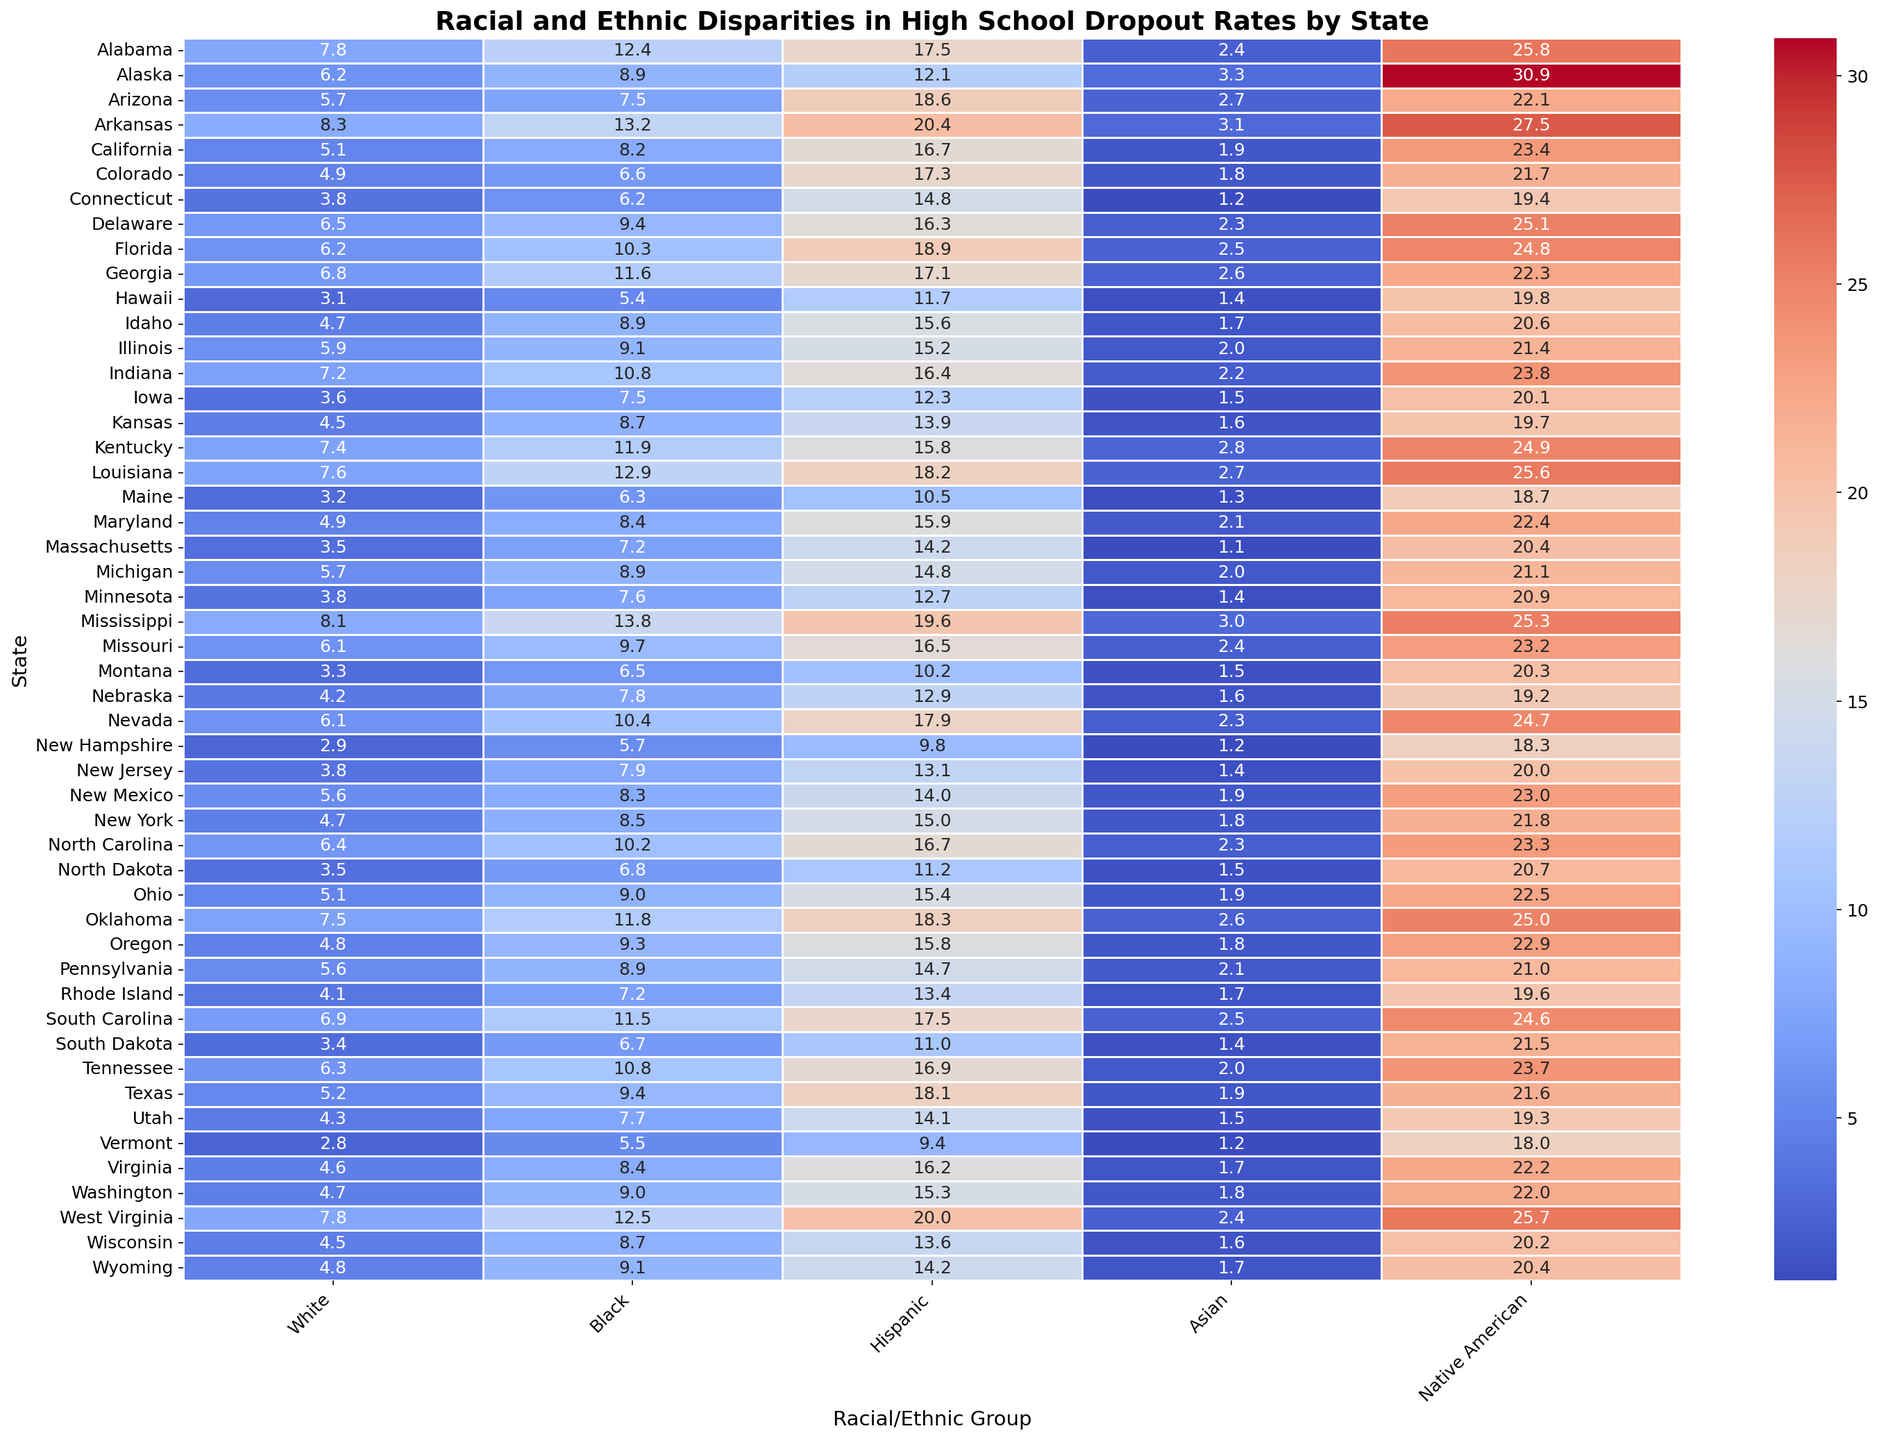What is the average dropout rate for Hispanic students across all states? To find the average dropout rate for Hispanic students, sum up all the dropout rates for the Hispanic column and divide by the number of states (50). Sum = 17.5 + 12.1 + 18.6 + 20.4 + 16.7 + 17.3 + 14.8 + 16.3 + 18.9 + 17.1 + 11.7 + 15.6 + 15.2 + 16.4 + 12.3 + 13.9 + 15.8 + 18.2 + 10.5 + 15.9 + 14.2 + 14.8 + 12.7 + 19.6 + 16.5 + 10.2 + 12.9 + 17.9 + 9.8 + 13.1 + 14.0 + 15.0 + 16.7 + 11.2 + 15.4 + 18.3 + 15.8 + 14.7 + 13.4 + 17.5 + 11.0 + 16.9 + 18.1 + 14.1 + 9.4 + 16.2 + 15.3 + 20.0 + 14.2 = 747.0. Average = 747.0 / 50 = 14.9
Answer: 14.9 Which state has the highest dropout rate for Native American students, and what is the rate? To find the state with the highest dropout rate for Native American students, scan through the Native American column and identify the maximum value and corresponding state. The highest rate is in Alaska with a 30.9% dropout rate.
Answer: Alaska, 30.9% How does the dropout rate for Black students in Mississippi compare to that in Kentucky? Look at the dropout rates for Black students in Mississippi and Kentucky, which are 13.8% and 11.9% respectively. Subtract 11.9 from 13.8 to find the difference. Mississippi's rate is 1.9 percentage points higher.
Answer: Mississippi, 1.9 percentage points higher What is the difference in dropout rates between White and Asian students in California? Subtract the dropout rate of Asian students in California (1.9%) from that of White students (5.1%). The difference is 5.1% - 1.9% = 3.2%.
Answer: 3.2% Which racial/ethnic group has the lowest dropout rate in New York? Look at the dropout rates for New York across all racial/ethnic groups: White (4.7%), Black (8.5%), Hispanic (15.0%), Asian (1.8%), Native American (21.8%). The lowest dropout rate is for Asian students at 1.8%.
Answer: Asian, 1.8% What is the sum of dropout rates for Hispanic students and Native American students in Texas? Add the dropout rate for Hispanic students (18.1%) to that for Native American students (21.6%). The sum is 18.1% + 21.6% = 39.7%.
Answer: 39.7% Identify the state with the lowest overall dropout rate for White students and the rate. Review the dropout rates for White students across all states and find the minimum value and corresponding state. Vermont has the lowest rate at 2.8%.
Answer: Vermont, 2.8% Compare the dropout rate for Hispanic students in Arkansas to that in Oklahoma. Which state has the higher rate, and by how much? Observe the dropout rates for Hispanic students in Arkansas (20.4%) and Oklahoma (18.3%). Subtract 18.3 from 20.4 to find the difference. Arkansas has a higher rate by 2.1 percentage points.
Answer: Arkansas, 2.1 percentage points higher 